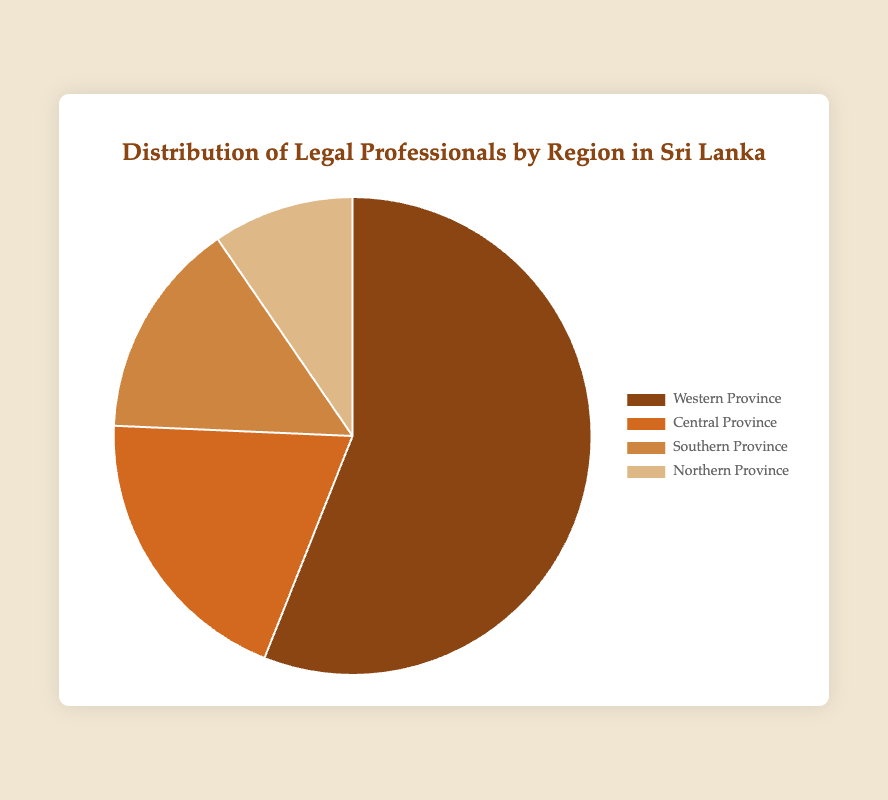Which region has the highest number of legal professionals? The Western Province has the highest count with 20,500 legal professionals compared to the other regions.
Answer: Western Province Which region has the smallest number of legal professionals? The Northern Province has the smallest count with 3,500 legal professionals.
Answer: Northern Province What is the total number of legal professionals across all regions? Add the number of legal professionals in all regions: 20,500 (Western Province) + 7,200 (Central Province) + 5,400 (Southern Province) + 3,500 (Northern Province) = 36,600
Answer: 36,600 What percentage of the total legal professionals are based in the Central Province? The Central Province has 7,200 legal professionals. To find the percentage: (7,200 / 36,600) * 100 ≈ 19.67%
Answer: ~19.67% How does the number of legal professionals in the Southern Province compare to the Northern Province? The Southern Province has 5,400 legal professionals, while the Northern Province has 3,500. Therefore, the Southern Province has 1,900 more legal professionals than the Northern Province.
Answer: Southern Province has 1,900 more What is the sum of legal professionals in the Central and Southern Provinces? Add the number of legal professionals in the Central Province (7,200) and the Southern Province (5,400): 7,200 + 5,400 = 12,600
Answer: 12,600 How many more legal professionals are there in the Western Province compared to the Central Province? Subtract the number of legal professionals in the Central Province (7,200) from those in the Western Province (20,500): 20,500 - 7,200 = 13,300
Answer: 13,300 Which region has a pie chart segment with a slightly darker brown color compared to Central Province? The Southern Province segment is slightly darker brown compared to the Central Province.
Answer: Southern Province What is the ratio of legal professionals between the Northern and Western Provinces? The number of legal professionals in the Northern Province is 3,500 and in the Western Province is 20,500. The ratio is 3,500:20,500, which simplifies to 1:5.86
Answer: 1:5.86 If you combine the number of legal professionals in the Central and Northern Provinces, does it surpass the number in the Western Province? The combined total of legal professionals in the Central (7,200) and Northern (3,500) Provinces is 7,200 + 3,500 = 10,700. This is less than the 20,500 in the Western Province, so it does not surpass it.
Answer: No 